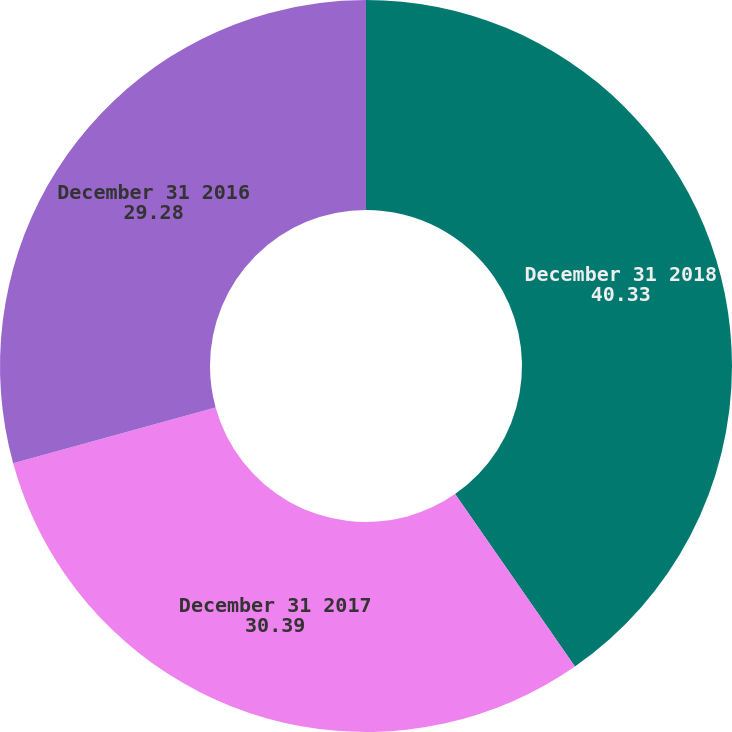<chart> <loc_0><loc_0><loc_500><loc_500><pie_chart><fcel>December 31 2018<fcel>December 31 2017<fcel>December 31 2016<nl><fcel>40.33%<fcel>30.39%<fcel>29.28%<nl></chart> 